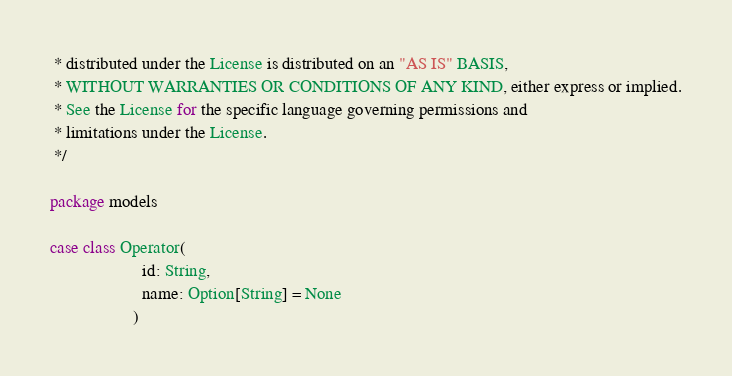Convert code to text. <code><loc_0><loc_0><loc_500><loc_500><_Scala_> * distributed under the License is distributed on an "AS IS" BASIS,
 * WITHOUT WARRANTIES OR CONDITIONS OF ANY KIND, either express or implied.
 * See the License for the specific language governing permissions and
 * limitations under the License.
 */

package models

case class Operator(
                     id: String,
                     name: Option[String] = None
                   )
</code> 